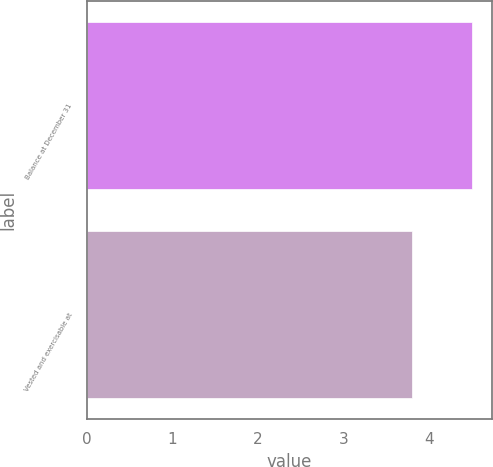Convert chart. <chart><loc_0><loc_0><loc_500><loc_500><bar_chart><fcel>Balance at December 31<fcel>Vested and exercisable at<nl><fcel>4.5<fcel>3.8<nl></chart> 